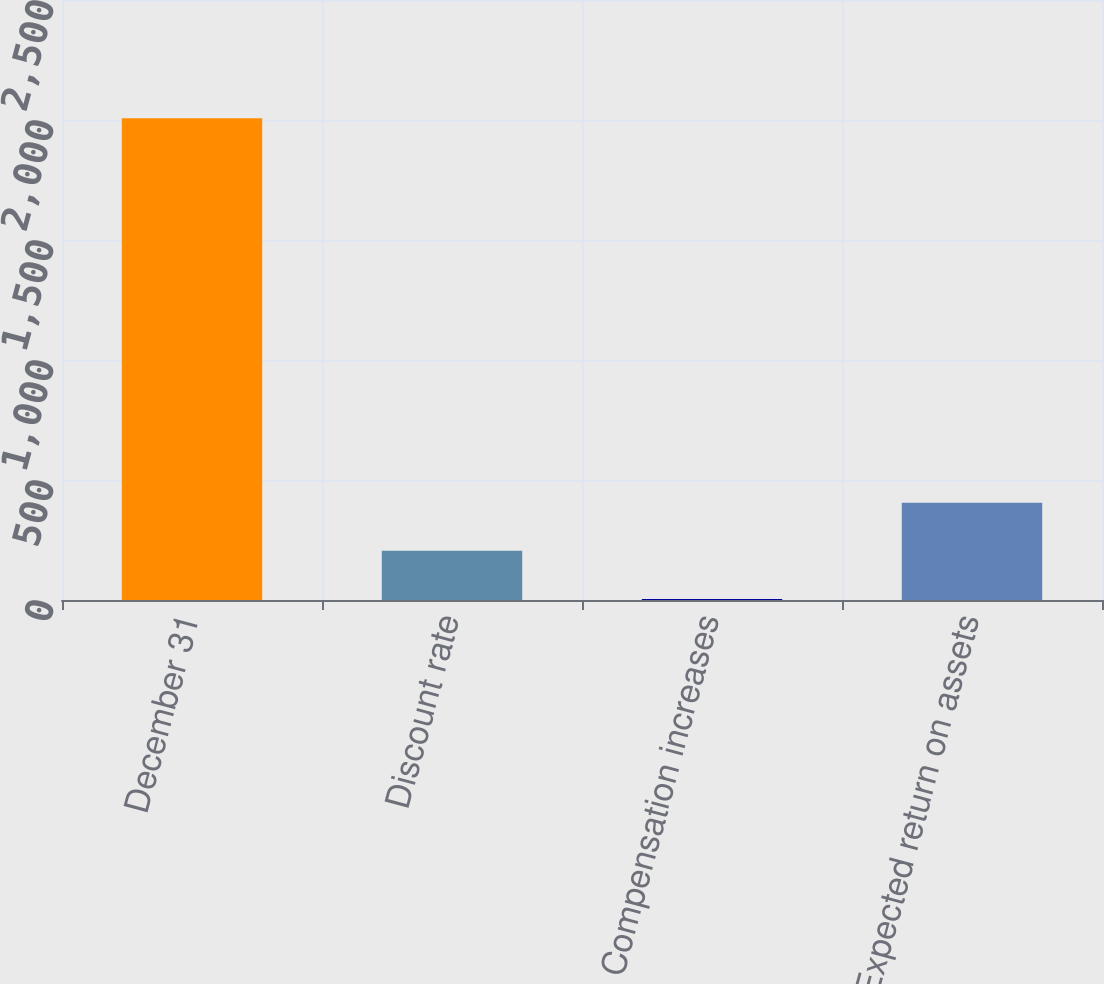Convert chart. <chart><loc_0><loc_0><loc_500><loc_500><bar_chart><fcel>December 31<fcel>Discount rate<fcel>Compensation increases<fcel>Expected return on assets<nl><fcel>2007<fcel>204.75<fcel>4.5<fcel>405<nl></chart> 